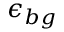Convert formula to latex. <formula><loc_0><loc_0><loc_500><loc_500>\epsilon _ { b g }</formula> 